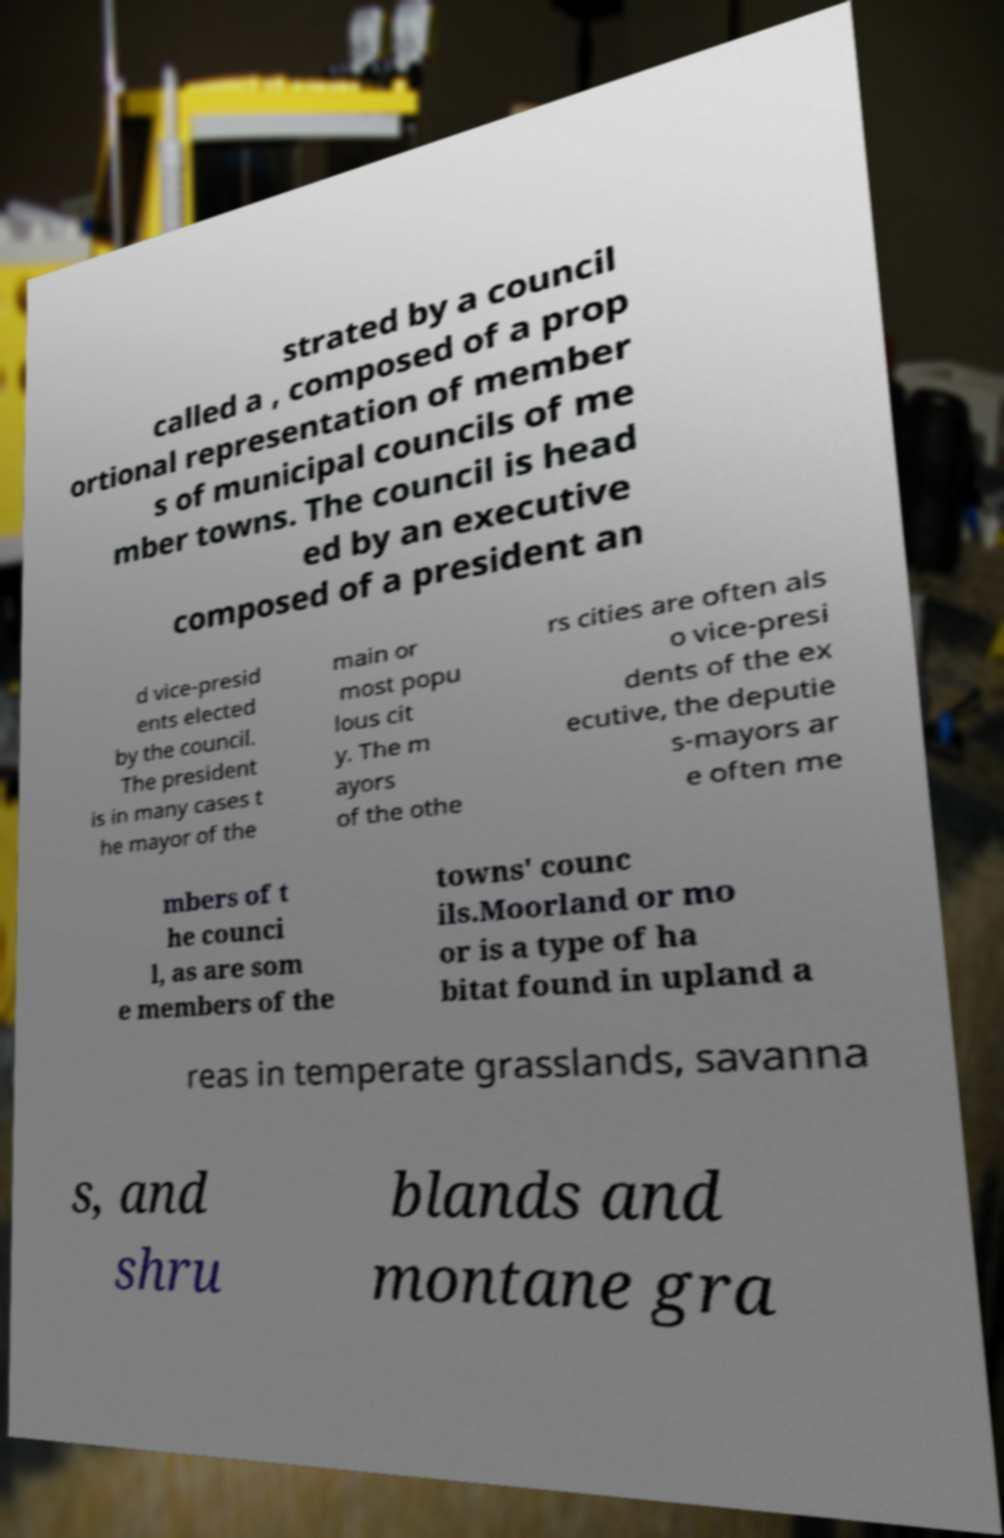There's text embedded in this image that I need extracted. Can you transcribe it verbatim? strated by a council called a , composed of a prop ortional representation of member s of municipal councils of me mber towns. The council is head ed by an executive composed of a president an d vice-presid ents elected by the council. The president is in many cases t he mayor of the main or most popu lous cit y. The m ayors of the othe rs cities are often als o vice-presi dents of the ex ecutive, the deputie s-mayors ar e often me mbers of t he counci l, as are som e members of the towns' counc ils.Moorland or mo or is a type of ha bitat found in upland a reas in temperate grasslands, savanna s, and shru blands and montane gra 